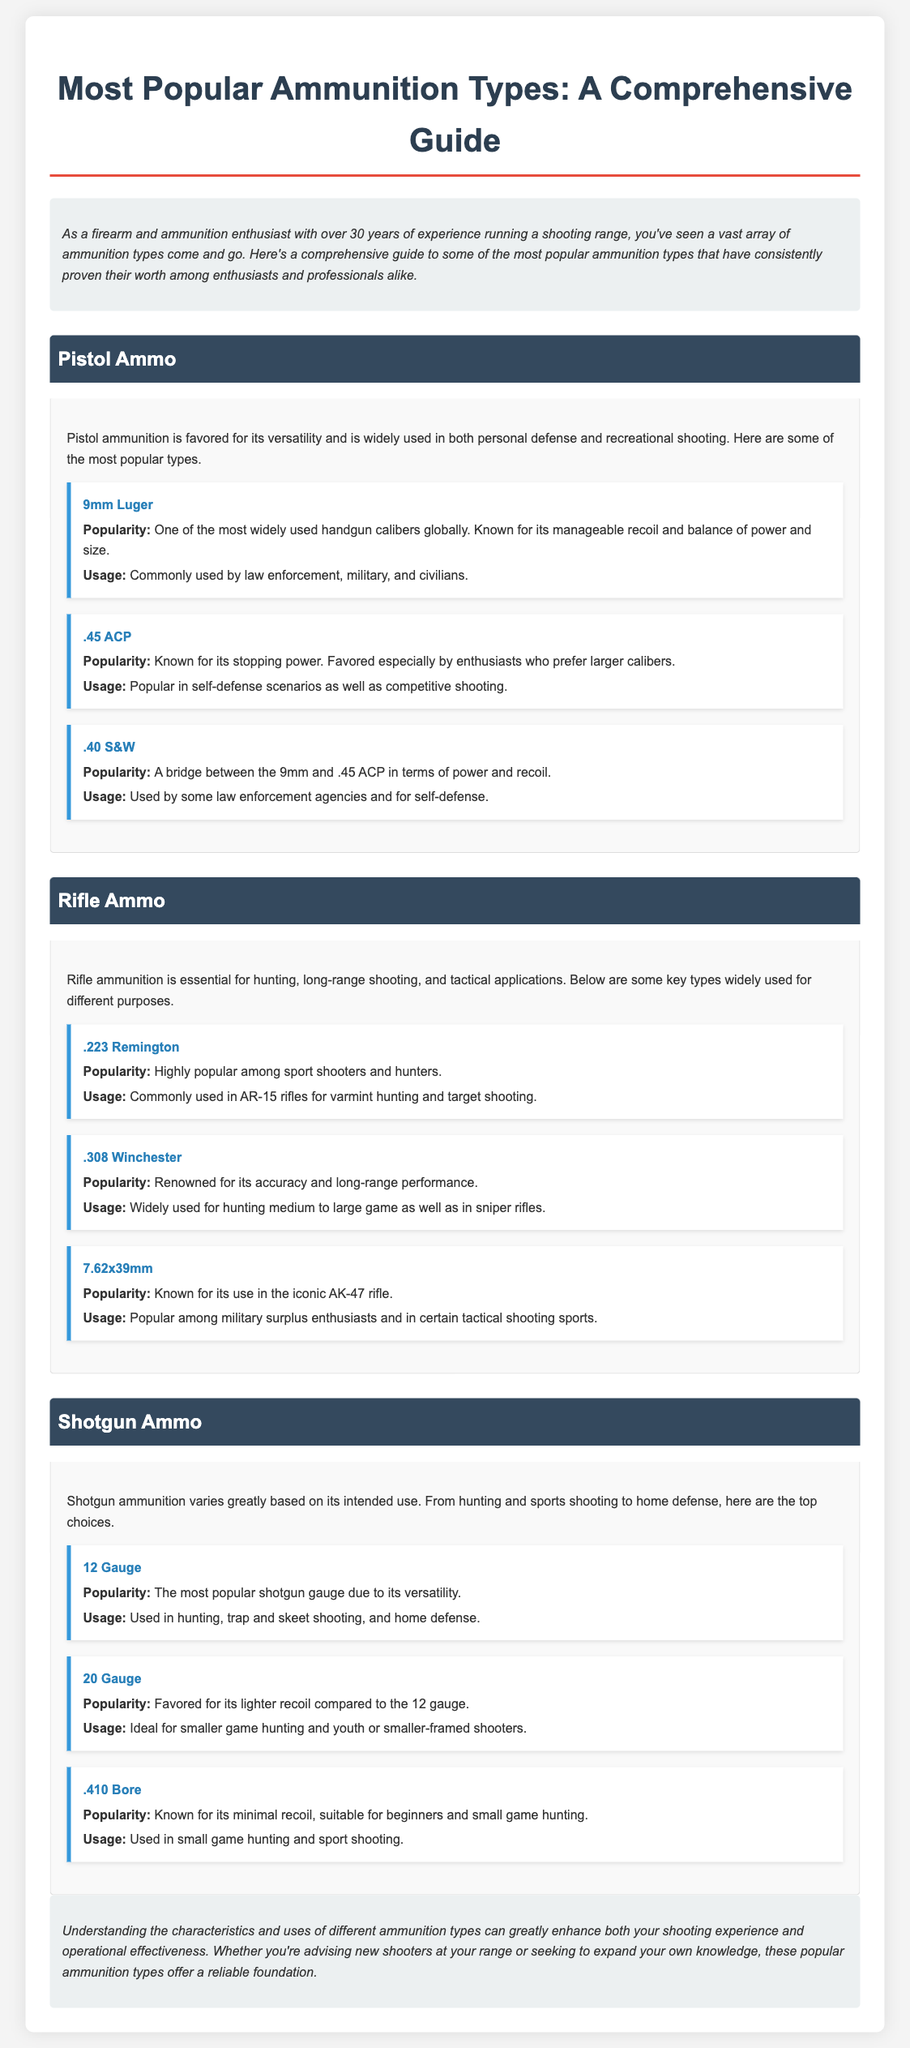what is one of the most widely used handgun calibers globally? The document states that the 9mm Luger is one of the most widely used handgun calibers globally.
Answer: 9mm Luger which shotgun gauge is noted for its versatility? The document highlights that the 12 Gauge is the most popular shotgun gauge due to its versatility.
Answer: 12 Gauge what type of ammunition is commonly used in AR-15 rifles? The .223 Remington is commonly used in AR-15 rifles for varmint hunting and target shooting according to the document.
Answer: .223 Remington how long has the author been running a shooting range? The introduction mentions that the author has over 30 years of experience running a shooting range.
Answer: over 30 years which pistol ammunition is known for its stopping power? The document indicates that .45 ACP is known for its stopping power.
Answer: .45 ACP what is a favored shotgun ammo for smaller game hunting? The 20 Gauge is favored for smaller game hunting according to the document.
Answer: 20 Gauge how is .40 S&W described in terms of power and recoil? The document describes .40 S&W as a bridge between the 9mm and .45 ACP in terms of power and recoil.
Answer: bridge between 9mm and .45 ACP which rifle ammunition is renowned for its accuracy and long-range performance? The .308 Winchester is renowned for its accuracy and long-range performance as stated in the document.
Answer: .308 Winchester what is one typical usage of 7.62x39mm ammunition? The document mentions that 7.62x39mm is popular among military surplus enthusiasts and in certain tactical shooting sports.
Answer: military surplus enthusiasts 